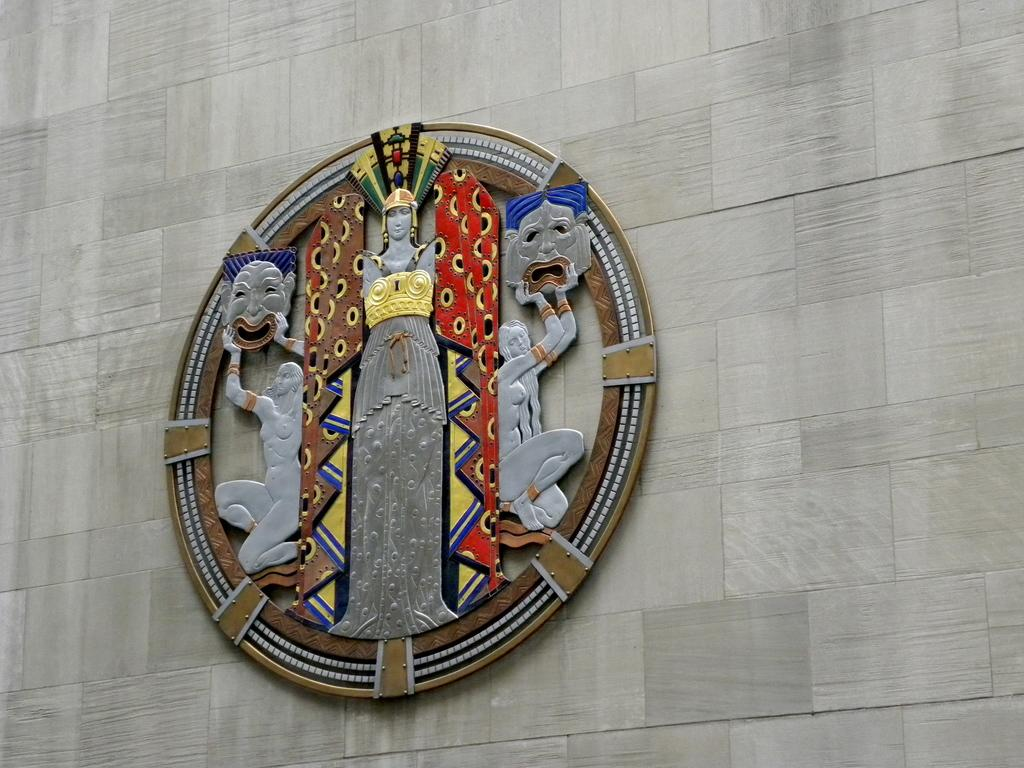What can be seen in the background of the image? There is a wall in the background of the image. What is on the wall in the image? There is a board on the wall. Absurd Question/Answer: How many rabbits are sitting on the board in the image? There are no rabbits present in the image; it only features a wall with a board on it. What type of material is the sponge made of in the image? There is no sponge present in the image, so we cannot determine its material. Similarly, there is no mention of leather in the image, so we cannot discuss any leather items. 